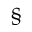<formula> <loc_0><loc_0><loc_500><loc_500>\quad ^ { \S }</formula> 